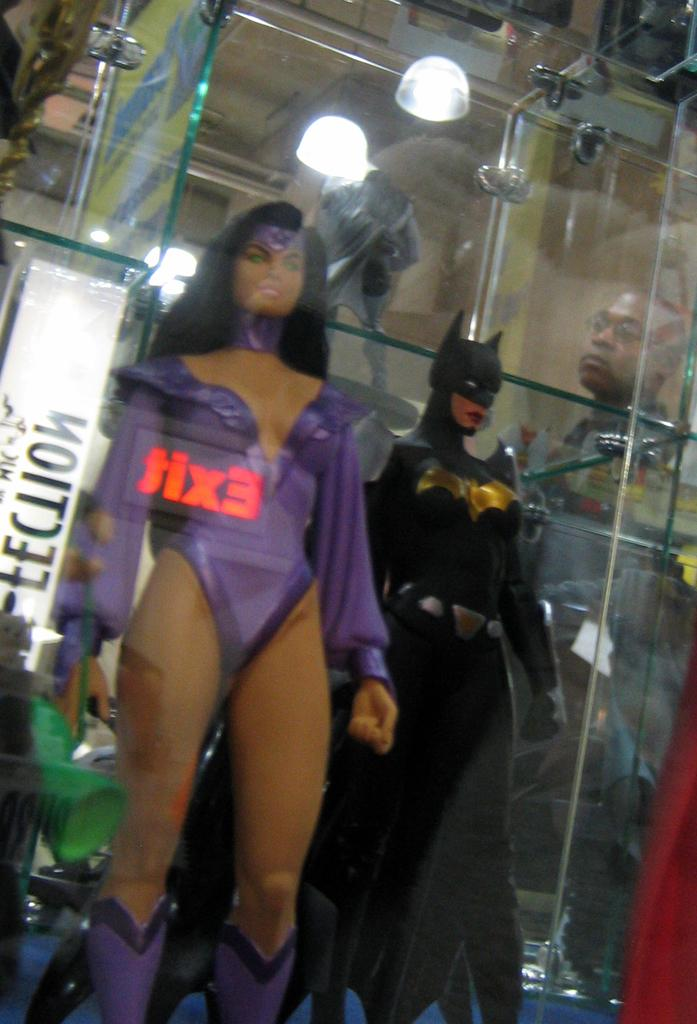What objects can be seen inside the glass in the image? There are two different toys in a glass in the image. What is visible at the top of the image? There is a light at the top of the image. Who is looking at the toys in the image? A woman is looking at the toys on the right side of the image. What type of stamp can be seen on the woman's forehead in the image? There is no stamp visible on the woman's forehead in the image. 